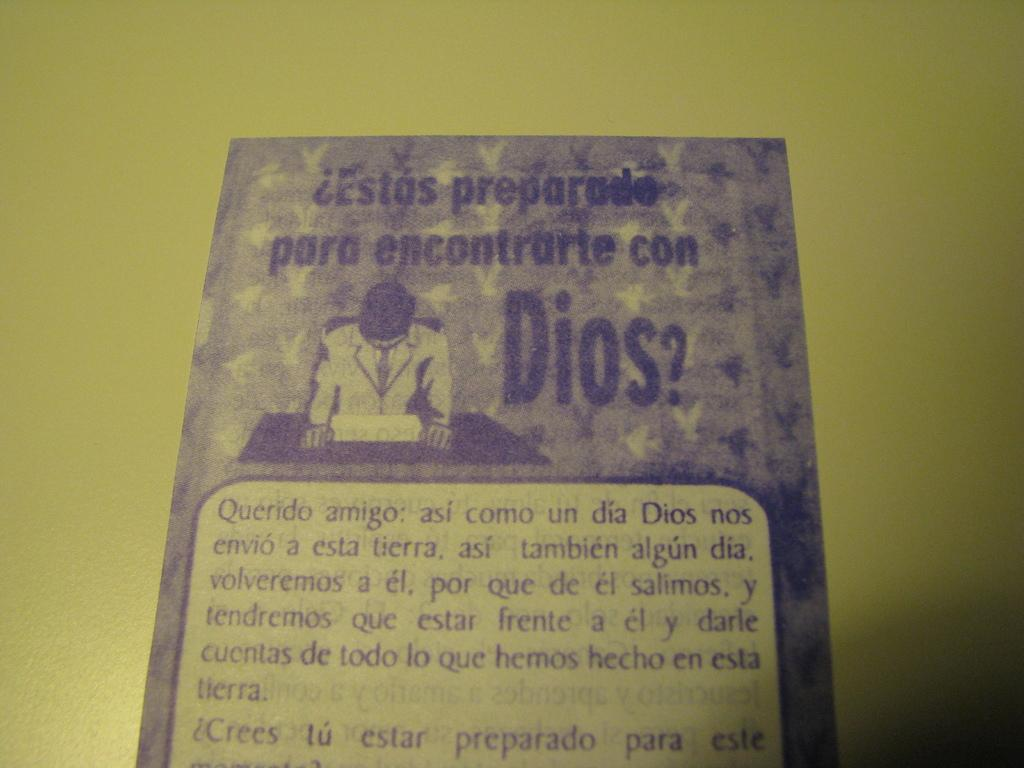<image>
Summarize the visual content of the image. a paper that says 'estas preparade para encontrarte con dios?' on it 